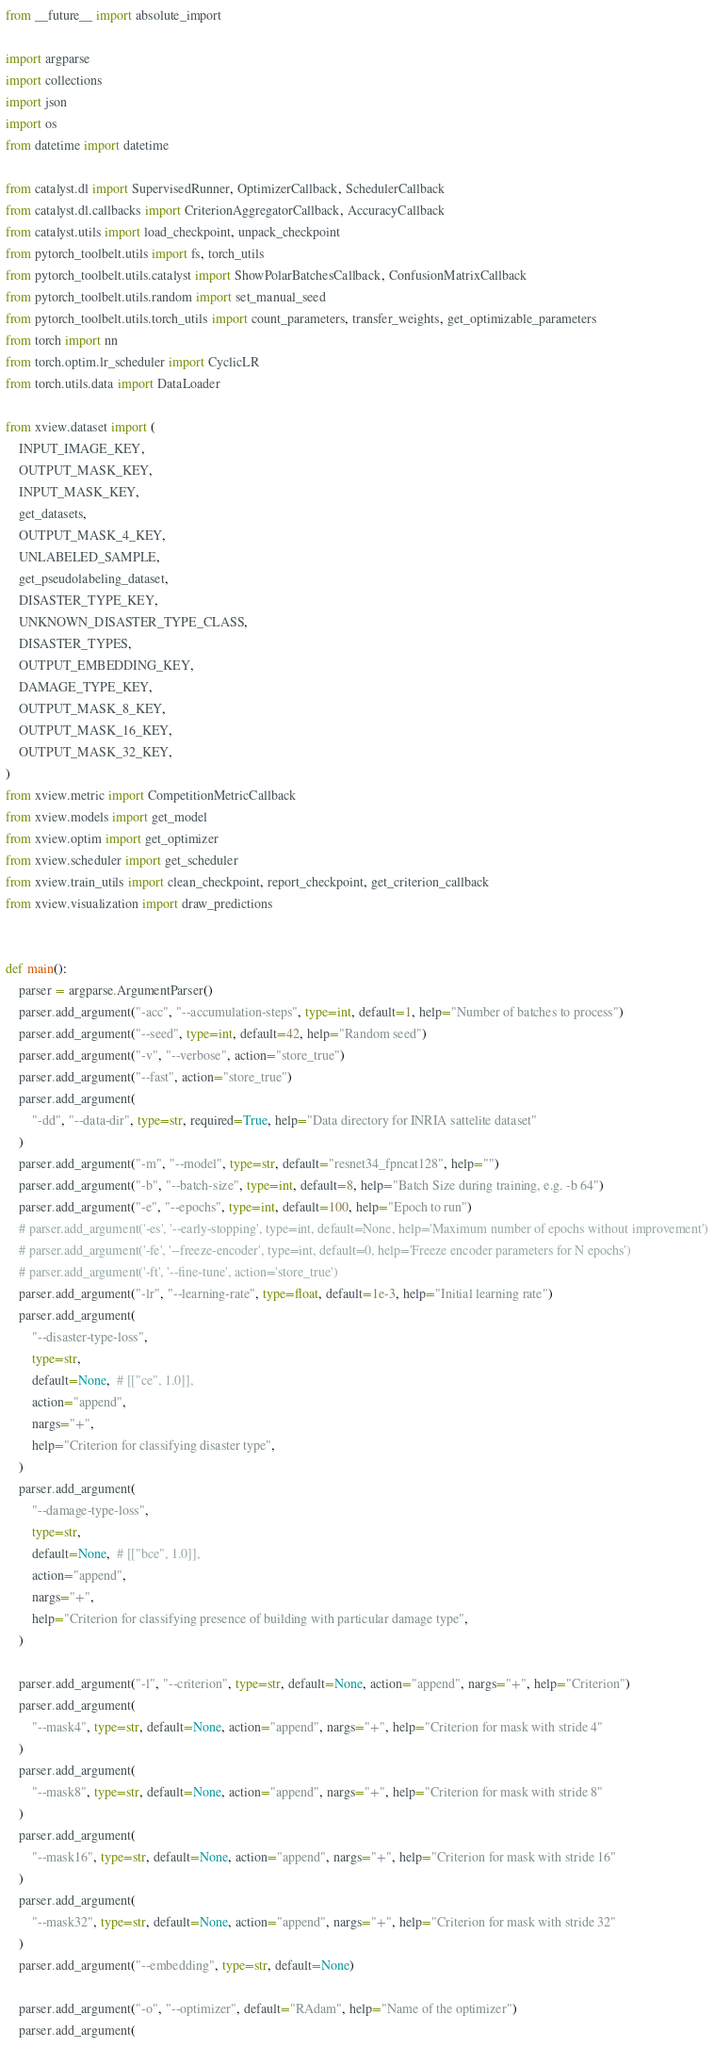<code> <loc_0><loc_0><loc_500><loc_500><_Python_>from __future__ import absolute_import

import argparse
import collections
import json
import os
from datetime import datetime

from catalyst.dl import SupervisedRunner, OptimizerCallback, SchedulerCallback
from catalyst.dl.callbacks import CriterionAggregatorCallback, AccuracyCallback
from catalyst.utils import load_checkpoint, unpack_checkpoint
from pytorch_toolbelt.utils import fs, torch_utils
from pytorch_toolbelt.utils.catalyst import ShowPolarBatchesCallback, ConfusionMatrixCallback
from pytorch_toolbelt.utils.random import set_manual_seed
from pytorch_toolbelt.utils.torch_utils import count_parameters, transfer_weights, get_optimizable_parameters
from torch import nn
from torch.optim.lr_scheduler import CyclicLR
from torch.utils.data import DataLoader

from xview.dataset import (
    INPUT_IMAGE_KEY,
    OUTPUT_MASK_KEY,
    INPUT_MASK_KEY,
    get_datasets,
    OUTPUT_MASK_4_KEY,
    UNLABELED_SAMPLE,
    get_pseudolabeling_dataset,
    DISASTER_TYPE_KEY,
    UNKNOWN_DISASTER_TYPE_CLASS,
    DISASTER_TYPES,
    OUTPUT_EMBEDDING_KEY,
    DAMAGE_TYPE_KEY,
    OUTPUT_MASK_8_KEY,
    OUTPUT_MASK_16_KEY,
    OUTPUT_MASK_32_KEY,
)
from xview.metric import CompetitionMetricCallback
from xview.models import get_model
from xview.optim import get_optimizer
from xview.scheduler import get_scheduler
from xview.train_utils import clean_checkpoint, report_checkpoint, get_criterion_callback
from xview.visualization import draw_predictions


def main():
    parser = argparse.ArgumentParser()
    parser.add_argument("-acc", "--accumulation-steps", type=int, default=1, help="Number of batches to process")
    parser.add_argument("--seed", type=int, default=42, help="Random seed")
    parser.add_argument("-v", "--verbose", action="store_true")
    parser.add_argument("--fast", action="store_true")
    parser.add_argument(
        "-dd", "--data-dir", type=str, required=True, help="Data directory for INRIA sattelite dataset"
    )
    parser.add_argument("-m", "--model", type=str, default="resnet34_fpncat128", help="")
    parser.add_argument("-b", "--batch-size", type=int, default=8, help="Batch Size during training, e.g. -b 64")
    parser.add_argument("-e", "--epochs", type=int, default=100, help="Epoch to run")
    # parser.add_argument('-es', '--early-stopping', type=int, default=None, help='Maximum number of epochs without improvement')
    # parser.add_argument('-fe', '--freeze-encoder', type=int, default=0, help='Freeze encoder parameters for N epochs')
    # parser.add_argument('-ft', '--fine-tune', action='store_true')
    parser.add_argument("-lr", "--learning-rate", type=float, default=1e-3, help="Initial learning rate")
    parser.add_argument(
        "--disaster-type-loss",
        type=str,
        default=None,  # [["ce", 1.0]],
        action="append",
        nargs="+",
        help="Criterion for classifying disaster type",
    )
    parser.add_argument(
        "--damage-type-loss",
        type=str,
        default=None,  # [["bce", 1.0]],
        action="append",
        nargs="+",
        help="Criterion for classifying presence of building with particular damage type",
    )

    parser.add_argument("-l", "--criterion", type=str, default=None, action="append", nargs="+", help="Criterion")
    parser.add_argument(
        "--mask4", type=str, default=None, action="append", nargs="+", help="Criterion for mask with stride 4"
    )
    parser.add_argument(
        "--mask8", type=str, default=None, action="append", nargs="+", help="Criterion for mask with stride 8"
    )
    parser.add_argument(
        "--mask16", type=str, default=None, action="append", nargs="+", help="Criterion for mask with stride 16"
    )
    parser.add_argument(
        "--mask32", type=str, default=None, action="append", nargs="+", help="Criterion for mask with stride 32"
    )
    parser.add_argument("--embedding", type=str, default=None)

    parser.add_argument("-o", "--optimizer", default="RAdam", help="Name of the optimizer")
    parser.add_argument(</code> 